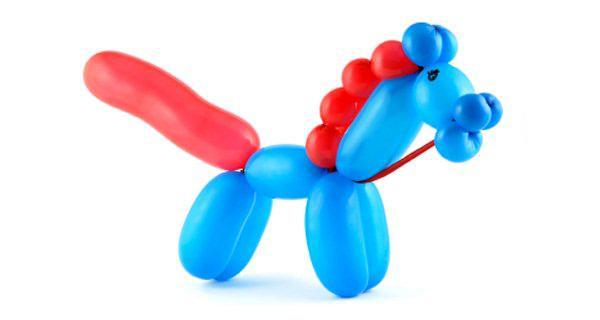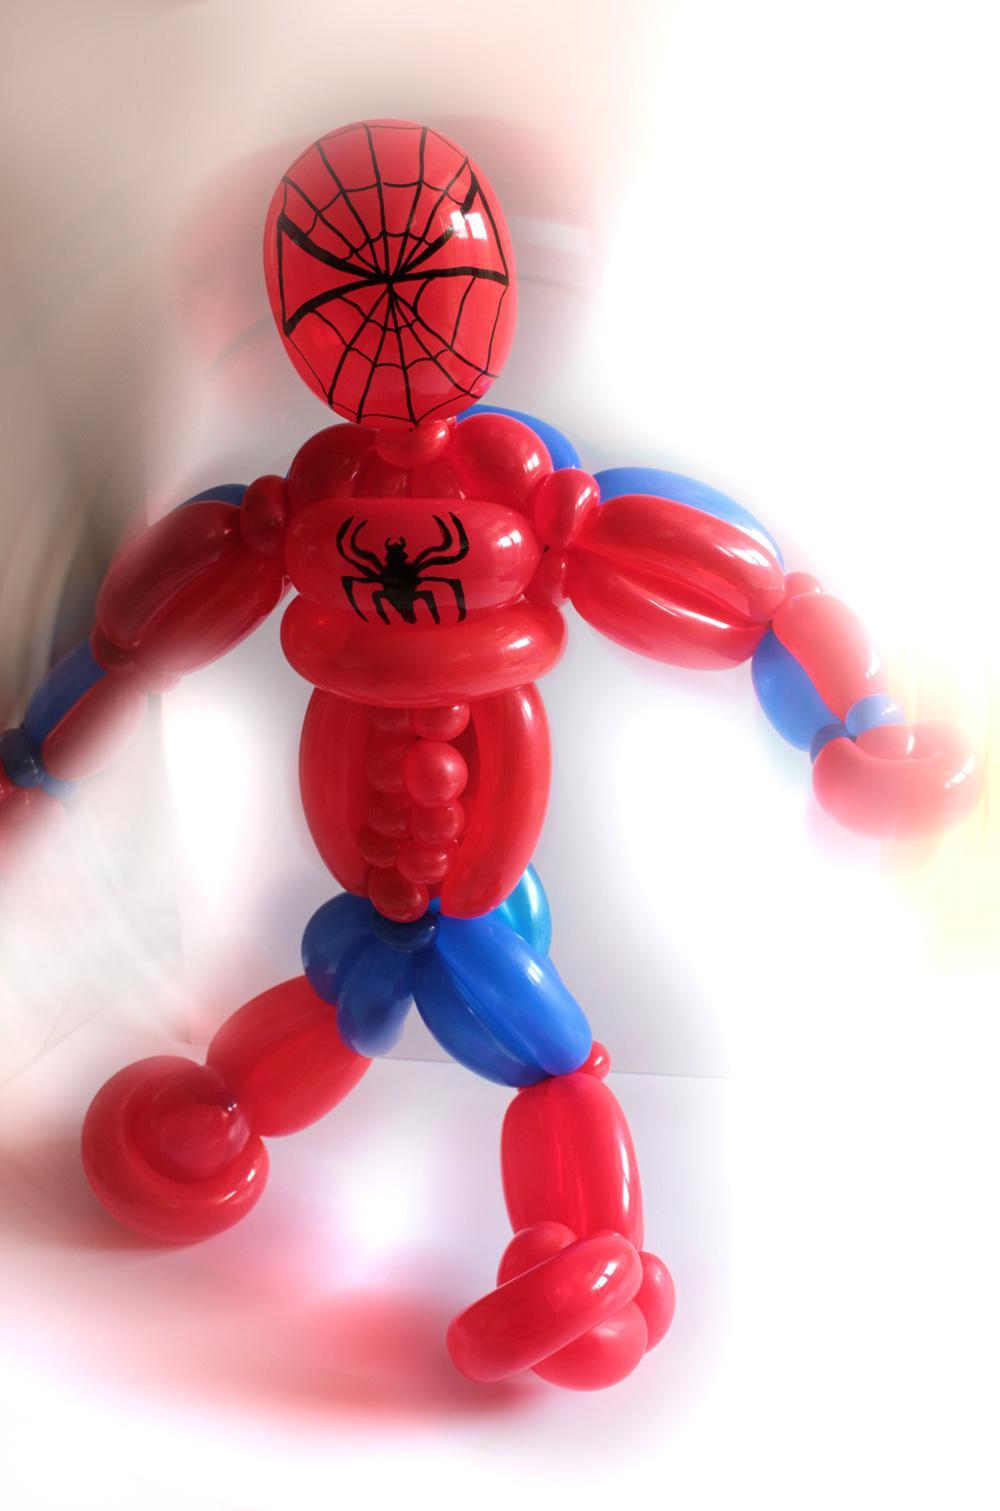The first image is the image on the left, the second image is the image on the right. For the images displayed, is the sentence "One of the balloons is shaped like spiderman." factually correct? Answer yes or no. Yes. 